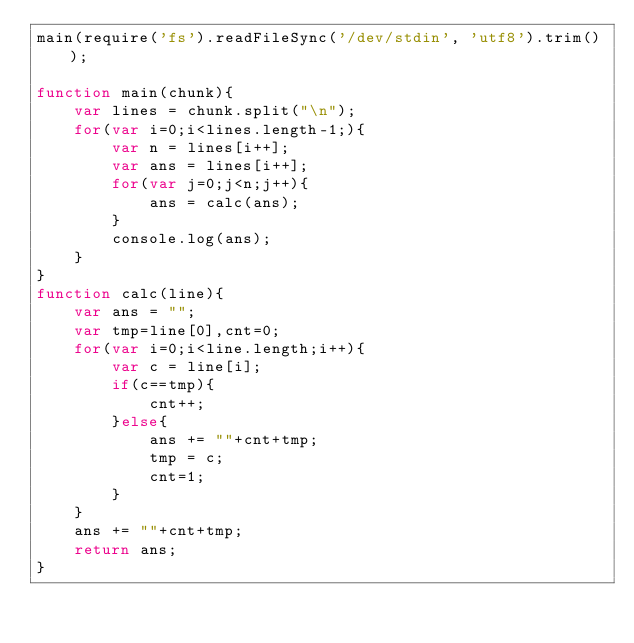<code> <loc_0><loc_0><loc_500><loc_500><_JavaScript_>main(require('fs').readFileSync('/dev/stdin', 'utf8').trim());

function main(chunk){
    var lines = chunk.split("\n");
    for(var i=0;i<lines.length-1;){
        var n = lines[i++];
        var ans = lines[i++];
        for(var j=0;j<n;j++){
            ans = calc(ans);
        }
        console.log(ans);
    }
}
function calc(line){
    var ans = "";
    var tmp=line[0],cnt=0;
    for(var i=0;i<line.length;i++){
        var c = line[i];
        if(c==tmp){
            cnt++;
        }else{
            ans += ""+cnt+tmp;
            tmp = c;
            cnt=1;
        }
    }
    ans += ""+cnt+tmp;
    return ans;
}</code> 